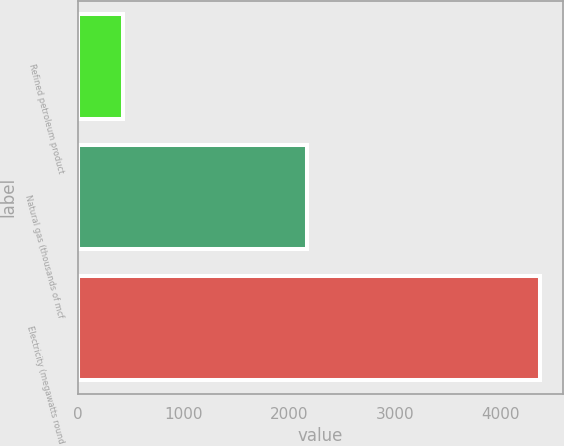<chart> <loc_0><loc_0><loc_500><loc_500><bar_chart><fcel>Refined petroleum product<fcel>Natural gas (thousands of mcf<fcel>Electricity (megawatts round<nl><fcel>430<fcel>2167<fcel>4374<nl></chart> 